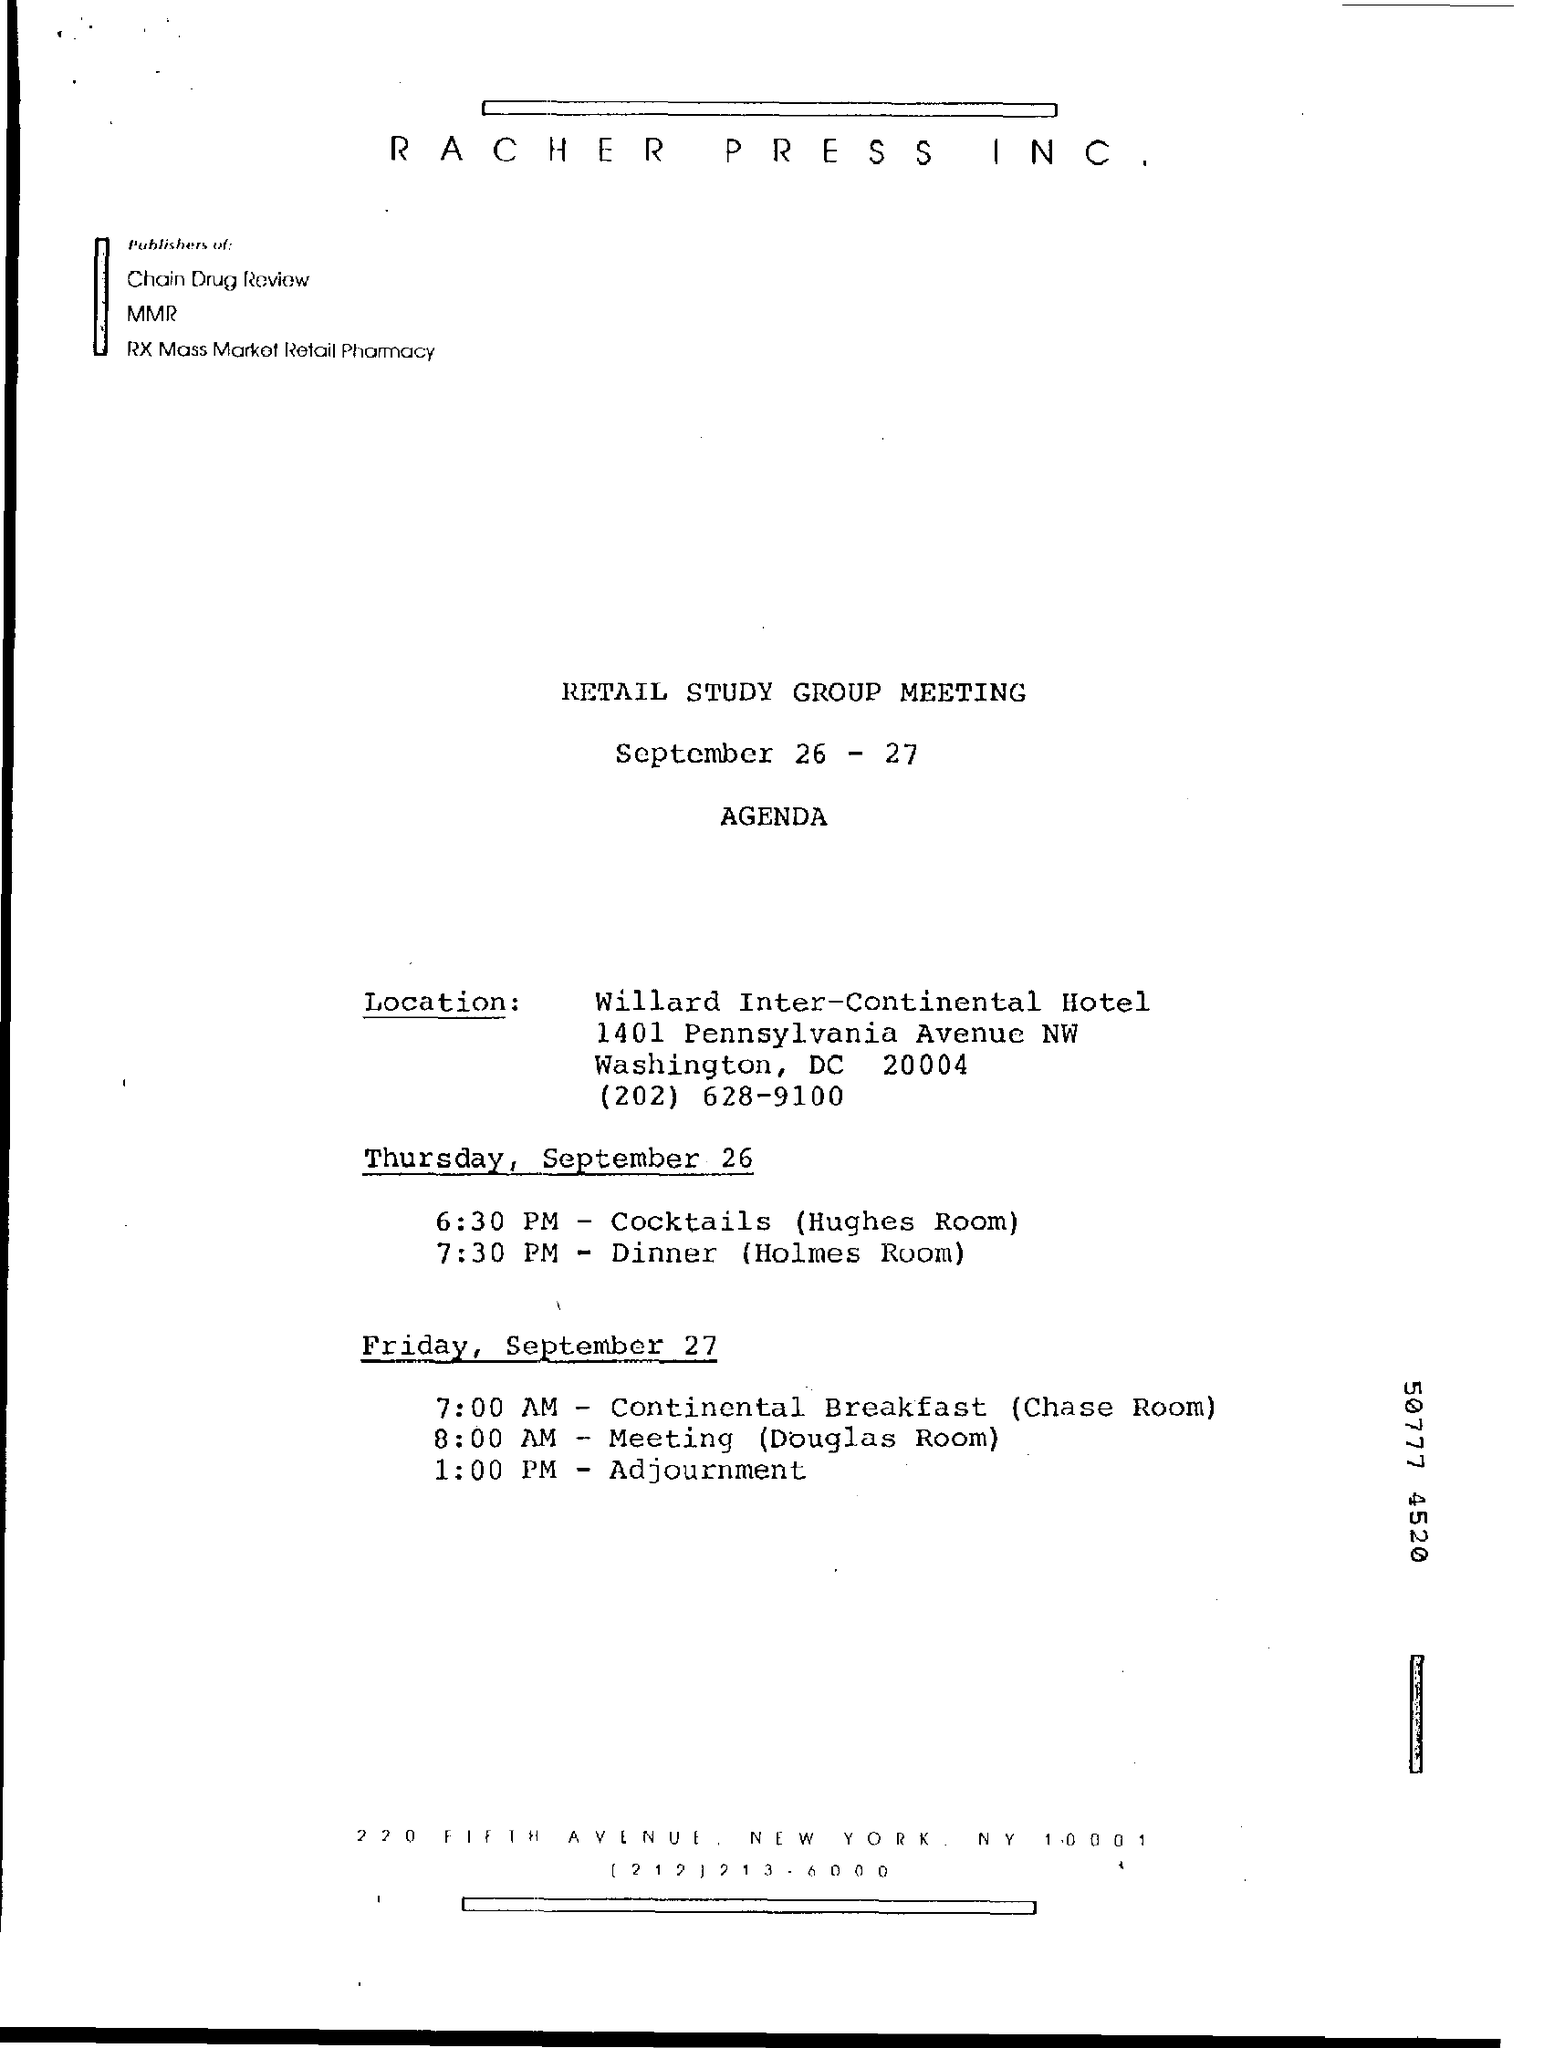Mention a couple of crucial points in this snapshot. The retail study group meeting was held on September 26-27. Thursday, September 26th, dinner will be served at 7:30 PM. Hughes Room is a room in which cocktails are served. On the date of Friday, September 27, continental breakfast will be served. Continental breakfast is served in the chase room. 